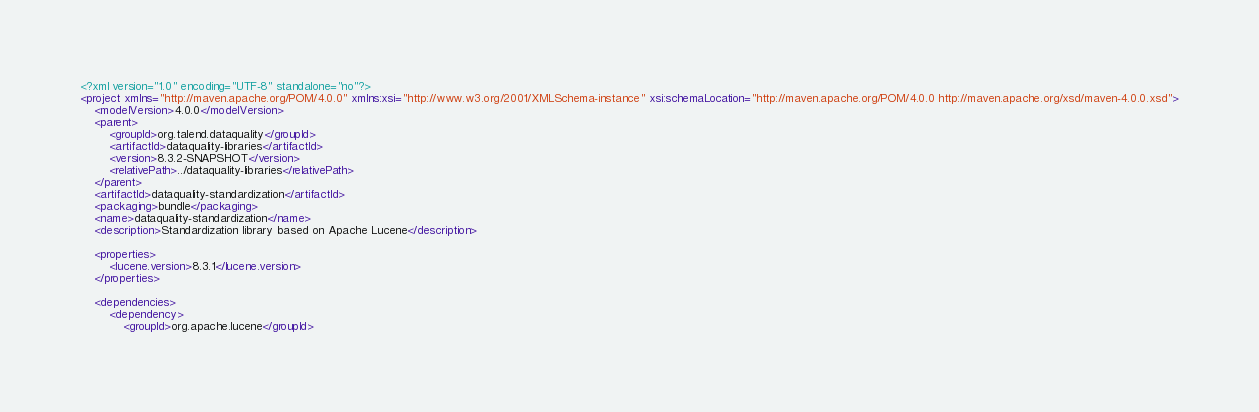<code> <loc_0><loc_0><loc_500><loc_500><_XML_><?xml version="1.0" encoding="UTF-8" standalone="no"?>
<project xmlns="http://maven.apache.org/POM/4.0.0" xmlns:xsi="http://www.w3.org/2001/XMLSchema-instance" xsi:schemaLocation="http://maven.apache.org/POM/4.0.0 http://maven.apache.org/xsd/maven-4.0.0.xsd">
	<modelVersion>4.0.0</modelVersion>
	<parent>
		<groupId>org.talend.dataquality</groupId>
		<artifactId>dataquality-libraries</artifactId>
		<version>8.3.2-SNAPSHOT</version>
		<relativePath>../dataquality-libraries</relativePath>
	</parent>
	<artifactId>dataquality-standardization</artifactId>
	<packaging>bundle</packaging>
	<name>dataquality-standardization</name>
	<description>Standardization library based on Apache Lucene</description>

	<properties>
		<lucene.version>8.3.1</lucene.version>
	</properties>

	<dependencies>
		<dependency>
			<groupId>org.apache.lucene</groupId></code> 